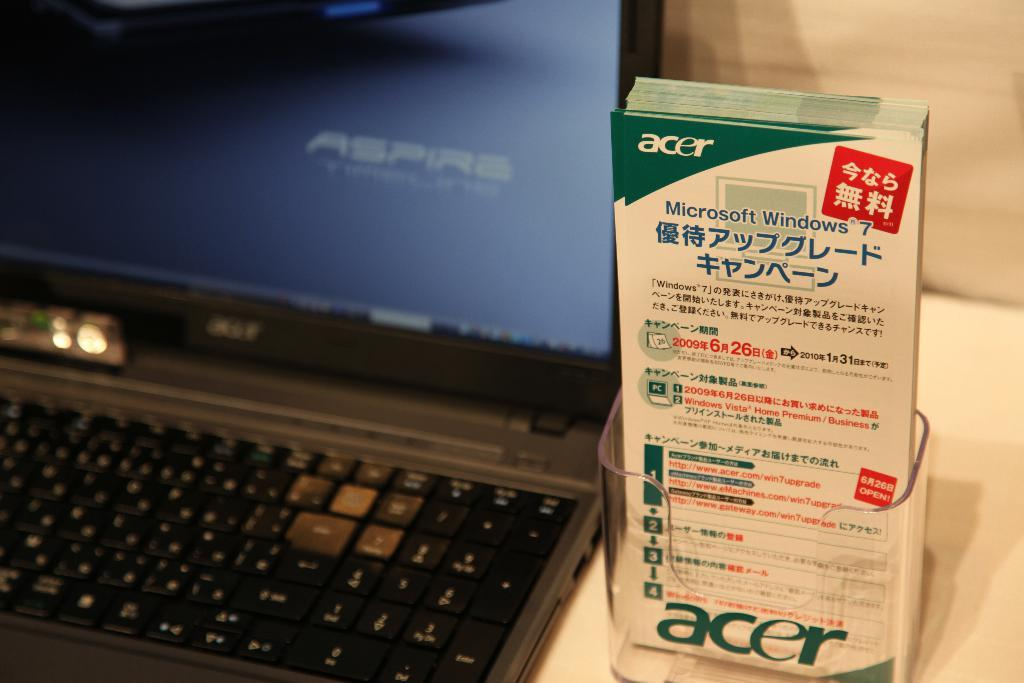<image>
Write a terse but informative summary of the picture. An Acer laptop sits next to some advertisement pamphlets. 